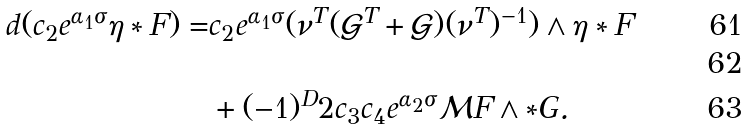Convert formula to latex. <formula><loc_0><loc_0><loc_500><loc_500>d ( c _ { 2 } e ^ { \alpha _ { 1 } \sigma } \eta \ast F ) = & c _ { 2 } e ^ { \alpha _ { 1 } \sigma } ( \nu ^ { T } ( \mathcal { G } ^ { T } + \mathcal { G } ) ( \nu ^ { T } ) ^ { - 1 } ) \wedge \eta \ast F \\ \\ & + ( - 1 ) ^ { D } 2 c _ { 3 } c _ { 4 } e ^ { \alpha _ { 2 } \sigma } \mathcal { M } F \wedge \ast G .</formula> 